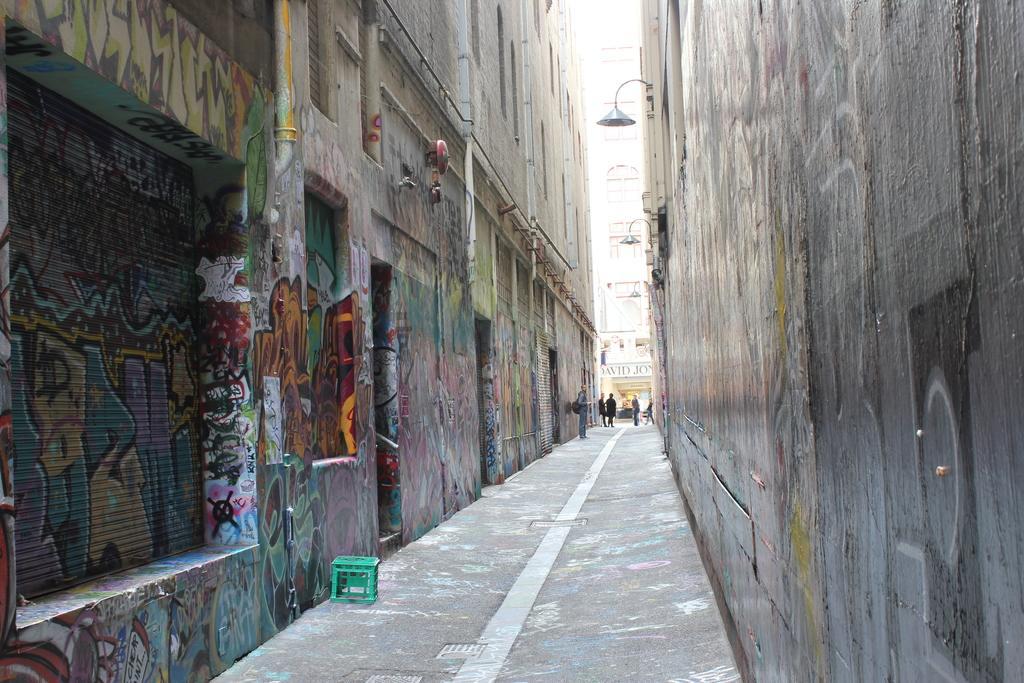In one or two sentences, can you explain what this image depicts? In the image i can see alley view,chairpersons,buildings,lamp. 